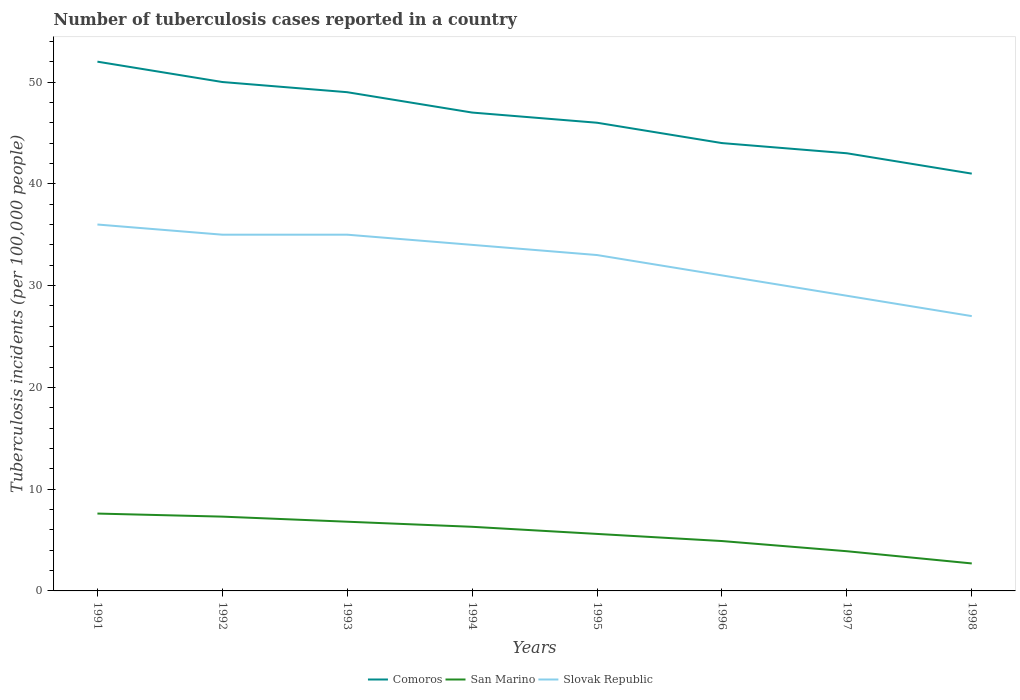Does the line corresponding to Slovak Republic intersect with the line corresponding to San Marino?
Your response must be concise. No. Across all years, what is the maximum number of tuberculosis cases reported in in Slovak Republic?
Offer a terse response. 27. In which year was the number of tuberculosis cases reported in in San Marino maximum?
Your answer should be compact. 1998. What is the difference between the highest and the second highest number of tuberculosis cases reported in in Comoros?
Your response must be concise. 11. Is the number of tuberculosis cases reported in in Slovak Republic strictly greater than the number of tuberculosis cases reported in in Comoros over the years?
Provide a succinct answer. Yes. What is the difference between two consecutive major ticks on the Y-axis?
Ensure brevity in your answer.  10. Are the values on the major ticks of Y-axis written in scientific E-notation?
Offer a terse response. No. Does the graph contain any zero values?
Offer a very short reply. No. Does the graph contain grids?
Provide a succinct answer. No. How are the legend labels stacked?
Provide a succinct answer. Horizontal. What is the title of the graph?
Give a very brief answer. Number of tuberculosis cases reported in a country. Does "Peru" appear as one of the legend labels in the graph?
Your answer should be compact. No. What is the label or title of the X-axis?
Offer a terse response. Years. What is the label or title of the Y-axis?
Your response must be concise. Tuberculosis incidents (per 100,0 people). What is the Tuberculosis incidents (per 100,000 people) in San Marino in 1991?
Your answer should be very brief. 7.6. What is the Tuberculosis incidents (per 100,000 people) of Slovak Republic in 1992?
Your answer should be compact. 35. What is the Tuberculosis incidents (per 100,000 people) in San Marino in 1994?
Your answer should be compact. 6.3. What is the Tuberculosis incidents (per 100,000 people) of Slovak Republic in 1994?
Give a very brief answer. 34. What is the Tuberculosis incidents (per 100,000 people) of Comoros in 1995?
Keep it short and to the point. 46. What is the Tuberculosis incidents (per 100,000 people) of Slovak Republic in 1995?
Ensure brevity in your answer.  33. What is the Tuberculosis incidents (per 100,000 people) of San Marino in 1996?
Give a very brief answer. 4.9. What is the Tuberculosis incidents (per 100,000 people) of San Marino in 1997?
Offer a very short reply. 3.9. What is the Tuberculosis incidents (per 100,000 people) in Comoros in 1998?
Keep it short and to the point. 41. What is the Tuberculosis incidents (per 100,000 people) in Slovak Republic in 1998?
Provide a short and direct response. 27. Across all years, what is the maximum Tuberculosis incidents (per 100,000 people) in Comoros?
Make the answer very short. 52. Across all years, what is the maximum Tuberculosis incidents (per 100,000 people) in Slovak Republic?
Give a very brief answer. 36. Across all years, what is the minimum Tuberculosis incidents (per 100,000 people) in San Marino?
Make the answer very short. 2.7. Across all years, what is the minimum Tuberculosis incidents (per 100,000 people) in Slovak Republic?
Offer a terse response. 27. What is the total Tuberculosis incidents (per 100,000 people) in Comoros in the graph?
Your answer should be compact. 372. What is the total Tuberculosis incidents (per 100,000 people) of San Marino in the graph?
Make the answer very short. 45.1. What is the total Tuberculosis incidents (per 100,000 people) in Slovak Republic in the graph?
Provide a short and direct response. 260. What is the difference between the Tuberculosis incidents (per 100,000 people) in Comoros in 1991 and that in 1992?
Offer a very short reply. 2. What is the difference between the Tuberculosis incidents (per 100,000 people) of San Marino in 1991 and that in 1993?
Ensure brevity in your answer.  0.8. What is the difference between the Tuberculosis incidents (per 100,000 people) in Slovak Republic in 1991 and that in 1993?
Your answer should be very brief. 1. What is the difference between the Tuberculosis incidents (per 100,000 people) of Comoros in 1991 and that in 1994?
Give a very brief answer. 5. What is the difference between the Tuberculosis incidents (per 100,000 people) in San Marino in 1991 and that in 1994?
Give a very brief answer. 1.3. What is the difference between the Tuberculosis incidents (per 100,000 people) of Comoros in 1991 and that in 1995?
Ensure brevity in your answer.  6. What is the difference between the Tuberculosis incidents (per 100,000 people) in Slovak Republic in 1991 and that in 1995?
Give a very brief answer. 3. What is the difference between the Tuberculosis incidents (per 100,000 people) of Comoros in 1991 and that in 1996?
Provide a succinct answer. 8. What is the difference between the Tuberculosis incidents (per 100,000 people) in San Marino in 1991 and that in 1998?
Keep it short and to the point. 4.9. What is the difference between the Tuberculosis incidents (per 100,000 people) in Comoros in 1992 and that in 1993?
Make the answer very short. 1. What is the difference between the Tuberculosis incidents (per 100,000 people) in San Marino in 1992 and that in 1993?
Offer a very short reply. 0.5. What is the difference between the Tuberculosis incidents (per 100,000 people) in San Marino in 1992 and that in 1994?
Ensure brevity in your answer.  1. What is the difference between the Tuberculosis incidents (per 100,000 people) of Slovak Republic in 1992 and that in 1995?
Offer a terse response. 2. What is the difference between the Tuberculosis incidents (per 100,000 people) of San Marino in 1992 and that in 1996?
Your response must be concise. 2.4. What is the difference between the Tuberculosis incidents (per 100,000 people) in Slovak Republic in 1992 and that in 1996?
Your response must be concise. 4. What is the difference between the Tuberculosis incidents (per 100,000 people) in Comoros in 1992 and that in 1997?
Keep it short and to the point. 7. What is the difference between the Tuberculosis incidents (per 100,000 people) in San Marino in 1992 and that in 1997?
Give a very brief answer. 3.4. What is the difference between the Tuberculosis incidents (per 100,000 people) of Slovak Republic in 1992 and that in 1997?
Keep it short and to the point. 6. What is the difference between the Tuberculosis incidents (per 100,000 people) in Slovak Republic in 1992 and that in 1998?
Provide a short and direct response. 8. What is the difference between the Tuberculosis incidents (per 100,000 people) of San Marino in 1993 and that in 1994?
Make the answer very short. 0.5. What is the difference between the Tuberculosis incidents (per 100,000 people) in Slovak Republic in 1993 and that in 1994?
Provide a succinct answer. 1. What is the difference between the Tuberculosis incidents (per 100,000 people) in Comoros in 1993 and that in 1995?
Ensure brevity in your answer.  3. What is the difference between the Tuberculosis incidents (per 100,000 people) of Slovak Republic in 1993 and that in 1995?
Make the answer very short. 2. What is the difference between the Tuberculosis incidents (per 100,000 people) of San Marino in 1993 and that in 1996?
Make the answer very short. 1.9. What is the difference between the Tuberculosis incidents (per 100,000 people) in Slovak Republic in 1993 and that in 1996?
Keep it short and to the point. 4. What is the difference between the Tuberculosis incidents (per 100,000 people) of Slovak Republic in 1993 and that in 1997?
Provide a short and direct response. 6. What is the difference between the Tuberculosis incidents (per 100,000 people) of Comoros in 1993 and that in 1998?
Provide a succinct answer. 8. What is the difference between the Tuberculosis incidents (per 100,000 people) of San Marino in 1994 and that in 1995?
Offer a very short reply. 0.7. What is the difference between the Tuberculosis incidents (per 100,000 people) of Comoros in 1994 and that in 1996?
Offer a terse response. 3. What is the difference between the Tuberculosis incidents (per 100,000 people) in Slovak Republic in 1994 and that in 1996?
Offer a very short reply. 3. What is the difference between the Tuberculosis incidents (per 100,000 people) in Comoros in 1994 and that in 1997?
Provide a succinct answer. 4. What is the difference between the Tuberculosis incidents (per 100,000 people) in Slovak Republic in 1994 and that in 1997?
Provide a short and direct response. 5. What is the difference between the Tuberculosis incidents (per 100,000 people) of Comoros in 1994 and that in 1998?
Keep it short and to the point. 6. What is the difference between the Tuberculosis incidents (per 100,000 people) in San Marino in 1994 and that in 1998?
Offer a terse response. 3.6. What is the difference between the Tuberculosis incidents (per 100,000 people) of Slovak Republic in 1994 and that in 1998?
Your response must be concise. 7. What is the difference between the Tuberculosis incidents (per 100,000 people) of Slovak Republic in 1995 and that in 1996?
Keep it short and to the point. 2. What is the difference between the Tuberculosis incidents (per 100,000 people) in Comoros in 1995 and that in 1998?
Give a very brief answer. 5. What is the difference between the Tuberculosis incidents (per 100,000 people) of Comoros in 1996 and that in 1997?
Your answer should be compact. 1. What is the difference between the Tuberculosis incidents (per 100,000 people) of San Marino in 1996 and that in 1997?
Provide a succinct answer. 1. What is the difference between the Tuberculosis incidents (per 100,000 people) in Slovak Republic in 1996 and that in 1997?
Make the answer very short. 2. What is the difference between the Tuberculosis incidents (per 100,000 people) in Comoros in 1997 and that in 1998?
Your answer should be compact. 2. What is the difference between the Tuberculosis incidents (per 100,000 people) of Slovak Republic in 1997 and that in 1998?
Offer a very short reply. 2. What is the difference between the Tuberculosis incidents (per 100,000 people) in Comoros in 1991 and the Tuberculosis incidents (per 100,000 people) in San Marino in 1992?
Offer a terse response. 44.7. What is the difference between the Tuberculosis incidents (per 100,000 people) in Comoros in 1991 and the Tuberculosis incidents (per 100,000 people) in Slovak Republic in 1992?
Offer a terse response. 17. What is the difference between the Tuberculosis incidents (per 100,000 people) in San Marino in 1991 and the Tuberculosis incidents (per 100,000 people) in Slovak Republic in 1992?
Your response must be concise. -27.4. What is the difference between the Tuberculosis incidents (per 100,000 people) in Comoros in 1991 and the Tuberculosis incidents (per 100,000 people) in San Marino in 1993?
Your answer should be very brief. 45.2. What is the difference between the Tuberculosis incidents (per 100,000 people) in Comoros in 1991 and the Tuberculosis incidents (per 100,000 people) in Slovak Republic in 1993?
Provide a short and direct response. 17. What is the difference between the Tuberculosis incidents (per 100,000 people) of San Marino in 1991 and the Tuberculosis incidents (per 100,000 people) of Slovak Republic in 1993?
Offer a very short reply. -27.4. What is the difference between the Tuberculosis incidents (per 100,000 people) in Comoros in 1991 and the Tuberculosis incidents (per 100,000 people) in San Marino in 1994?
Offer a very short reply. 45.7. What is the difference between the Tuberculosis incidents (per 100,000 people) in Comoros in 1991 and the Tuberculosis incidents (per 100,000 people) in Slovak Republic in 1994?
Ensure brevity in your answer.  18. What is the difference between the Tuberculosis incidents (per 100,000 people) of San Marino in 1991 and the Tuberculosis incidents (per 100,000 people) of Slovak Republic in 1994?
Provide a short and direct response. -26.4. What is the difference between the Tuberculosis incidents (per 100,000 people) of Comoros in 1991 and the Tuberculosis incidents (per 100,000 people) of San Marino in 1995?
Offer a terse response. 46.4. What is the difference between the Tuberculosis incidents (per 100,000 people) in Comoros in 1991 and the Tuberculosis incidents (per 100,000 people) in Slovak Republic in 1995?
Your answer should be compact. 19. What is the difference between the Tuberculosis incidents (per 100,000 people) of San Marino in 1991 and the Tuberculosis incidents (per 100,000 people) of Slovak Republic in 1995?
Your answer should be very brief. -25.4. What is the difference between the Tuberculosis incidents (per 100,000 people) in Comoros in 1991 and the Tuberculosis incidents (per 100,000 people) in San Marino in 1996?
Give a very brief answer. 47.1. What is the difference between the Tuberculosis incidents (per 100,000 people) in Comoros in 1991 and the Tuberculosis incidents (per 100,000 people) in Slovak Republic in 1996?
Give a very brief answer. 21. What is the difference between the Tuberculosis incidents (per 100,000 people) in San Marino in 1991 and the Tuberculosis incidents (per 100,000 people) in Slovak Republic in 1996?
Make the answer very short. -23.4. What is the difference between the Tuberculosis incidents (per 100,000 people) in Comoros in 1991 and the Tuberculosis incidents (per 100,000 people) in San Marino in 1997?
Your answer should be compact. 48.1. What is the difference between the Tuberculosis incidents (per 100,000 people) in Comoros in 1991 and the Tuberculosis incidents (per 100,000 people) in Slovak Republic in 1997?
Your answer should be very brief. 23. What is the difference between the Tuberculosis incidents (per 100,000 people) of San Marino in 1991 and the Tuberculosis incidents (per 100,000 people) of Slovak Republic in 1997?
Your response must be concise. -21.4. What is the difference between the Tuberculosis incidents (per 100,000 people) in Comoros in 1991 and the Tuberculosis incidents (per 100,000 people) in San Marino in 1998?
Provide a short and direct response. 49.3. What is the difference between the Tuberculosis incidents (per 100,000 people) in Comoros in 1991 and the Tuberculosis incidents (per 100,000 people) in Slovak Republic in 1998?
Keep it short and to the point. 25. What is the difference between the Tuberculosis incidents (per 100,000 people) in San Marino in 1991 and the Tuberculosis incidents (per 100,000 people) in Slovak Republic in 1998?
Your answer should be very brief. -19.4. What is the difference between the Tuberculosis incidents (per 100,000 people) of Comoros in 1992 and the Tuberculosis incidents (per 100,000 people) of San Marino in 1993?
Your answer should be very brief. 43.2. What is the difference between the Tuberculosis incidents (per 100,000 people) of Comoros in 1992 and the Tuberculosis incidents (per 100,000 people) of Slovak Republic in 1993?
Offer a terse response. 15. What is the difference between the Tuberculosis incidents (per 100,000 people) in San Marino in 1992 and the Tuberculosis incidents (per 100,000 people) in Slovak Republic in 1993?
Give a very brief answer. -27.7. What is the difference between the Tuberculosis incidents (per 100,000 people) of Comoros in 1992 and the Tuberculosis incidents (per 100,000 people) of San Marino in 1994?
Give a very brief answer. 43.7. What is the difference between the Tuberculosis incidents (per 100,000 people) of Comoros in 1992 and the Tuberculosis incidents (per 100,000 people) of Slovak Republic in 1994?
Provide a succinct answer. 16. What is the difference between the Tuberculosis incidents (per 100,000 people) in San Marino in 1992 and the Tuberculosis incidents (per 100,000 people) in Slovak Republic in 1994?
Give a very brief answer. -26.7. What is the difference between the Tuberculosis incidents (per 100,000 people) in Comoros in 1992 and the Tuberculosis incidents (per 100,000 people) in San Marino in 1995?
Offer a terse response. 44.4. What is the difference between the Tuberculosis incidents (per 100,000 people) of San Marino in 1992 and the Tuberculosis incidents (per 100,000 people) of Slovak Republic in 1995?
Provide a succinct answer. -25.7. What is the difference between the Tuberculosis incidents (per 100,000 people) in Comoros in 1992 and the Tuberculosis incidents (per 100,000 people) in San Marino in 1996?
Keep it short and to the point. 45.1. What is the difference between the Tuberculosis incidents (per 100,000 people) in San Marino in 1992 and the Tuberculosis incidents (per 100,000 people) in Slovak Republic in 1996?
Provide a succinct answer. -23.7. What is the difference between the Tuberculosis incidents (per 100,000 people) of Comoros in 1992 and the Tuberculosis incidents (per 100,000 people) of San Marino in 1997?
Offer a terse response. 46.1. What is the difference between the Tuberculosis incidents (per 100,000 people) in Comoros in 1992 and the Tuberculosis incidents (per 100,000 people) in Slovak Republic in 1997?
Make the answer very short. 21. What is the difference between the Tuberculosis incidents (per 100,000 people) in San Marino in 1992 and the Tuberculosis incidents (per 100,000 people) in Slovak Republic in 1997?
Offer a very short reply. -21.7. What is the difference between the Tuberculosis incidents (per 100,000 people) of Comoros in 1992 and the Tuberculosis incidents (per 100,000 people) of San Marino in 1998?
Ensure brevity in your answer.  47.3. What is the difference between the Tuberculosis incidents (per 100,000 people) in Comoros in 1992 and the Tuberculosis incidents (per 100,000 people) in Slovak Republic in 1998?
Your answer should be very brief. 23. What is the difference between the Tuberculosis incidents (per 100,000 people) of San Marino in 1992 and the Tuberculosis incidents (per 100,000 people) of Slovak Republic in 1998?
Your answer should be very brief. -19.7. What is the difference between the Tuberculosis incidents (per 100,000 people) of Comoros in 1993 and the Tuberculosis incidents (per 100,000 people) of San Marino in 1994?
Give a very brief answer. 42.7. What is the difference between the Tuberculosis incidents (per 100,000 people) of San Marino in 1993 and the Tuberculosis incidents (per 100,000 people) of Slovak Republic in 1994?
Ensure brevity in your answer.  -27.2. What is the difference between the Tuberculosis incidents (per 100,000 people) in Comoros in 1993 and the Tuberculosis incidents (per 100,000 people) in San Marino in 1995?
Make the answer very short. 43.4. What is the difference between the Tuberculosis incidents (per 100,000 people) in San Marino in 1993 and the Tuberculosis incidents (per 100,000 people) in Slovak Republic in 1995?
Your answer should be compact. -26.2. What is the difference between the Tuberculosis incidents (per 100,000 people) of Comoros in 1993 and the Tuberculosis incidents (per 100,000 people) of San Marino in 1996?
Offer a terse response. 44.1. What is the difference between the Tuberculosis incidents (per 100,000 people) of San Marino in 1993 and the Tuberculosis incidents (per 100,000 people) of Slovak Republic in 1996?
Ensure brevity in your answer.  -24.2. What is the difference between the Tuberculosis incidents (per 100,000 people) in Comoros in 1993 and the Tuberculosis incidents (per 100,000 people) in San Marino in 1997?
Your answer should be very brief. 45.1. What is the difference between the Tuberculosis incidents (per 100,000 people) of Comoros in 1993 and the Tuberculosis incidents (per 100,000 people) of Slovak Republic in 1997?
Your answer should be compact. 20. What is the difference between the Tuberculosis incidents (per 100,000 people) in San Marino in 1993 and the Tuberculosis incidents (per 100,000 people) in Slovak Republic in 1997?
Your response must be concise. -22.2. What is the difference between the Tuberculosis incidents (per 100,000 people) in Comoros in 1993 and the Tuberculosis incidents (per 100,000 people) in San Marino in 1998?
Your answer should be compact. 46.3. What is the difference between the Tuberculosis incidents (per 100,000 people) of San Marino in 1993 and the Tuberculosis incidents (per 100,000 people) of Slovak Republic in 1998?
Keep it short and to the point. -20.2. What is the difference between the Tuberculosis incidents (per 100,000 people) in Comoros in 1994 and the Tuberculosis incidents (per 100,000 people) in San Marino in 1995?
Give a very brief answer. 41.4. What is the difference between the Tuberculosis incidents (per 100,000 people) in San Marino in 1994 and the Tuberculosis incidents (per 100,000 people) in Slovak Republic in 1995?
Offer a very short reply. -26.7. What is the difference between the Tuberculosis incidents (per 100,000 people) of Comoros in 1994 and the Tuberculosis incidents (per 100,000 people) of San Marino in 1996?
Offer a terse response. 42.1. What is the difference between the Tuberculosis incidents (per 100,000 people) of San Marino in 1994 and the Tuberculosis incidents (per 100,000 people) of Slovak Republic in 1996?
Your answer should be very brief. -24.7. What is the difference between the Tuberculosis incidents (per 100,000 people) of Comoros in 1994 and the Tuberculosis incidents (per 100,000 people) of San Marino in 1997?
Offer a terse response. 43.1. What is the difference between the Tuberculosis incidents (per 100,000 people) in San Marino in 1994 and the Tuberculosis incidents (per 100,000 people) in Slovak Republic in 1997?
Keep it short and to the point. -22.7. What is the difference between the Tuberculosis incidents (per 100,000 people) in Comoros in 1994 and the Tuberculosis incidents (per 100,000 people) in San Marino in 1998?
Your answer should be very brief. 44.3. What is the difference between the Tuberculosis incidents (per 100,000 people) of Comoros in 1994 and the Tuberculosis incidents (per 100,000 people) of Slovak Republic in 1998?
Keep it short and to the point. 20. What is the difference between the Tuberculosis incidents (per 100,000 people) in San Marino in 1994 and the Tuberculosis incidents (per 100,000 people) in Slovak Republic in 1998?
Your answer should be very brief. -20.7. What is the difference between the Tuberculosis incidents (per 100,000 people) in Comoros in 1995 and the Tuberculosis incidents (per 100,000 people) in San Marino in 1996?
Your answer should be compact. 41.1. What is the difference between the Tuberculosis incidents (per 100,000 people) of San Marino in 1995 and the Tuberculosis incidents (per 100,000 people) of Slovak Republic in 1996?
Give a very brief answer. -25.4. What is the difference between the Tuberculosis incidents (per 100,000 people) of Comoros in 1995 and the Tuberculosis incidents (per 100,000 people) of San Marino in 1997?
Offer a terse response. 42.1. What is the difference between the Tuberculosis incidents (per 100,000 people) of San Marino in 1995 and the Tuberculosis incidents (per 100,000 people) of Slovak Republic in 1997?
Your answer should be very brief. -23.4. What is the difference between the Tuberculosis incidents (per 100,000 people) of Comoros in 1995 and the Tuberculosis incidents (per 100,000 people) of San Marino in 1998?
Offer a terse response. 43.3. What is the difference between the Tuberculosis incidents (per 100,000 people) in San Marino in 1995 and the Tuberculosis incidents (per 100,000 people) in Slovak Republic in 1998?
Provide a succinct answer. -21.4. What is the difference between the Tuberculosis incidents (per 100,000 people) in Comoros in 1996 and the Tuberculosis incidents (per 100,000 people) in San Marino in 1997?
Offer a terse response. 40.1. What is the difference between the Tuberculosis incidents (per 100,000 people) of San Marino in 1996 and the Tuberculosis incidents (per 100,000 people) of Slovak Republic in 1997?
Ensure brevity in your answer.  -24.1. What is the difference between the Tuberculosis incidents (per 100,000 people) in Comoros in 1996 and the Tuberculosis incidents (per 100,000 people) in San Marino in 1998?
Keep it short and to the point. 41.3. What is the difference between the Tuberculosis incidents (per 100,000 people) in Comoros in 1996 and the Tuberculosis incidents (per 100,000 people) in Slovak Republic in 1998?
Keep it short and to the point. 17. What is the difference between the Tuberculosis incidents (per 100,000 people) of San Marino in 1996 and the Tuberculosis incidents (per 100,000 people) of Slovak Republic in 1998?
Provide a succinct answer. -22.1. What is the difference between the Tuberculosis incidents (per 100,000 people) in Comoros in 1997 and the Tuberculosis incidents (per 100,000 people) in San Marino in 1998?
Provide a succinct answer. 40.3. What is the difference between the Tuberculosis incidents (per 100,000 people) of Comoros in 1997 and the Tuberculosis incidents (per 100,000 people) of Slovak Republic in 1998?
Provide a short and direct response. 16. What is the difference between the Tuberculosis incidents (per 100,000 people) of San Marino in 1997 and the Tuberculosis incidents (per 100,000 people) of Slovak Republic in 1998?
Give a very brief answer. -23.1. What is the average Tuberculosis incidents (per 100,000 people) in Comoros per year?
Ensure brevity in your answer.  46.5. What is the average Tuberculosis incidents (per 100,000 people) of San Marino per year?
Make the answer very short. 5.64. What is the average Tuberculosis incidents (per 100,000 people) in Slovak Republic per year?
Offer a very short reply. 32.5. In the year 1991, what is the difference between the Tuberculosis incidents (per 100,000 people) of Comoros and Tuberculosis incidents (per 100,000 people) of San Marino?
Offer a terse response. 44.4. In the year 1991, what is the difference between the Tuberculosis incidents (per 100,000 people) of San Marino and Tuberculosis incidents (per 100,000 people) of Slovak Republic?
Keep it short and to the point. -28.4. In the year 1992, what is the difference between the Tuberculosis incidents (per 100,000 people) in Comoros and Tuberculosis incidents (per 100,000 people) in San Marino?
Your answer should be compact. 42.7. In the year 1992, what is the difference between the Tuberculosis incidents (per 100,000 people) in Comoros and Tuberculosis incidents (per 100,000 people) in Slovak Republic?
Your response must be concise. 15. In the year 1992, what is the difference between the Tuberculosis incidents (per 100,000 people) in San Marino and Tuberculosis incidents (per 100,000 people) in Slovak Republic?
Offer a terse response. -27.7. In the year 1993, what is the difference between the Tuberculosis incidents (per 100,000 people) of Comoros and Tuberculosis incidents (per 100,000 people) of San Marino?
Your response must be concise. 42.2. In the year 1993, what is the difference between the Tuberculosis incidents (per 100,000 people) in Comoros and Tuberculosis incidents (per 100,000 people) in Slovak Republic?
Provide a short and direct response. 14. In the year 1993, what is the difference between the Tuberculosis incidents (per 100,000 people) of San Marino and Tuberculosis incidents (per 100,000 people) of Slovak Republic?
Your response must be concise. -28.2. In the year 1994, what is the difference between the Tuberculosis incidents (per 100,000 people) in Comoros and Tuberculosis incidents (per 100,000 people) in San Marino?
Give a very brief answer. 40.7. In the year 1994, what is the difference between the Tuberculosis incidents (per 100,000 people) of Comoros and Tuberculosis incidents (per 100,000 people) of Slovak Republic?
Provide a succinct answer. 13. In the year 1994, what is the difference between the Tuberculosis incidents (per 100,000 people) in San Marino and Tuberculosis incidents (per 100,000 people) in Slovak Republic?
Ensure brevity in your answer.  -27.7. In the year 1995, what is the difference between the Tuberculosis incidents (per 100,000 people) in Comoros and Tuberculosis incidents (per 100,000 people) in San Marino?
Offer a very short reply. 40.4. In the year 1995, what is the difference between the Tuberculosis incidents (per 100,000 people) in San Marino and Tuberculosis incidents (per 100,000 people) in Slovak Republic?
Give a very brief answer. -27.4. In the year 1996, what is the difference between the Tuberculosis incidents (per 100,000 people) in Comoros and Tuberculosis incidents (per 100,000 people) in San Marino?
Give a very brief answer. 39.1. In the year 1996, what is the difference between the Tuberculosis incidents (per 100,000 people) in San Marino and Tuberculosis incidents (per 100,000 people) in Slovak Republic?
Ensure brevity in your answer.  -26.1. In the year 1997, what is the difference between the Tuberculosis incidents (per 100,000 people) of Comoros and Tuberculosis incidents (per 100,000 people) of San Marino?
Your answer should be very brief. 39.1. In the year 1997, what is the difference between the Tuberculosis incidents (per 100,000 people) of Comoros and Tuberculosis incidents (per 100,000 people) of Slovak Republic?
Give a very brief answer. 14. In the year 1997, what is the difference between the Tuberculosis incidents (per 100,000 people) of San Marino and Tuberculosis incidents (per 100,000 people) of Slovak Republic?
Keep it short and to the point. -25.1. In the year 1998, what is the difference between the Tuberculosis incidents (per 100,000 people) of Comoros and Tuberculosis incidents (per 100,000 people) of San Marino?
Make the answer very short. 38.3. In the year 1998, what is the difference between the Tuberculosis incidents (per 100,000 people) in Comoros and Tuberculosis incidents (per 100,000 people) in Slovak Republic?
Give a very brief answer. 14. In the year 1998, what is the difference between the Tuberculosis incidents (per 100,000 people) in San Marino and Tuberculosis incidents (per 100,000 people) in Slovak Republic?
Provide a succinct answer. -24.3. What is the ratio of the Tuberculosis incidents (per 100,000 people) of Comoros in 1991 to that in 1992?
Offer a very short reply. 1.04. What is the ratio of the Tuberculosis incidents (per 100,000 people) of San Marino in 1991 to that in 1992?
Your answer should be very brief. 1.04. What is the ratio of the Tuberculosis incidents (per 100,000 people) in Slovak Republic in 1991 to that in 1992?
Ensure brevity in your answer.  1.03. What is the ratio of the Tuberculosis incidents (per 100,000 people) of Comoros in 1991 to that in 1993?
Your answer should be compact. 1.06. What is the ratio of the Tuberculosis incidents (per 100,000 people) of San Marino in 1991 to that in 1993?
Ensure brevity in your answer.  1.12. What is the ratio of the Tuberculosis incidents (per 100,000 people) in Slovak Republic in 1991 to that in 1993?
Your answer should be very brief. 1.03. What is the ratio of the Tuberculosis incidents (per 100,000 people) in Comoros in 1991 to that in 1994?
Ensure brevity in your answer.  1.11. What is the ratio of the Tuberculosis incidents (per 100,000 people) in San Marino in 1991 to that in 1994?
Your answer should be very brief. 1.21. What is the ratio of the Tuberculosis incidents (per 100,000 people) in Slovak Republic in 1991 to that in 1994?
Your response must be concise. 1.06. What is the ratio of the Tuberculosis incidents (per 100,000 people) in Comoros in 1991 to that in 1995?
Make the answer very short. 1.13. What is the ratio of the Tuberculosis incidents (per 100,000 people) in San Marino in 1991 to that in 1995?
Your answer should be compact. 1.36. What is the ratio of the Tuberculosis incidents (per 100,000 people) in Comoros in 1991 to that in 1996?
Give a very brief answer. 1.18. What is the ratio of the Tuberculosis incidents (per 100,000 people) in San Marino in 1991 to that in 1996?
Keep it short and to the point. 1.55. What is the ratio of the Tuberculosis incidents (per 100,000 people) of Slovak Republic in 1991 to that in 1996?
Your answer should be compact. 1.16. What is the ratio of the Tuberculosis incidents (per 100,000 people) in Comoros in 1991 to that in 1997?
Make the answer very short. 1.21. What is the ratio of the Tuberculosis incidents (per 100,000 people) of San Marino in 1991 to that in 1997?
Give a very brief answer. 1.95. What is the ratio of the Tuberculosis incidents (per 100,000 people) in Slovak Republic in 1991 to that in 1997?
Ensure brevity in your answer.  1.24. What is the ratio of the Tuberculosis incidents (per 100,000 people) of Comoros in 1991 to that in 1998?
Provide a succinct answer. 1.27. What is the ratio of the Tuberculosis incidents (per 100,000 people) in San Marino in 1991 to that in 1998?
Your response must be concise. 2.81. What is the ratio of the Tuberculosis incidents (per 100,000 people) in Slovak Republic in 1991 to that in 1998?
Keep it short and to the point. 1.33. What is the ratio of the Tuberculosis incidents (per 100,000 people) of Comoros in 1992 to that in 1993?
Give a very brief answer. 1.02. What is the ratio of the Tuberculosis incidents (per 100,000 people) of San Marino in 1992 to that in 1993?
Make the answer very short. 1.07. What is the ratio of the Tuberculosis incidents (per 100,000 people) of Comoros in 1992 to that in 1994?
Your answer should be compact. 1.06. What is the ratio of the Tuberculosis incidents (per 100,000 people) in San Marino in 1992 to that in 1994?
Make the answer very short. 1.16. What is the ratio of the Tuberculosis incidents (per 100,000 people) in Slovak Republic in 1992 to that in 1994?
Keep it short and to the point. 1.03. What is the ratio of the Tuberculosis incidents (per 100,000 people) of Comoros in 1992 to that in 1995?
Your response must be concise. 1.09. What is the ratio of the Tuberculosis incidents (per 100,000 people) in San Marino in 1992 to that in 1995?
Make the answer very short. 1.3. What is the ratio of the Tuberculosis incidents (per 100,000 people) of Slovak Republic in 1992 to that in 1995?
Offer a terse response. 1.06. What is the ratio of the Tuberculosis incidents (per 100,000 people) of Comoros in 1992 to that in 1996?
Your response must be concise. 1.14. What is the ratio of the Tuberculosis incidents (per 100,000 people) of San Marino in 1992 to that in 1996?
Your response must be concise. 1.49. What is the ratio of the Tuberculosis incidents (per 100,000 people) of Slovak Republic in 1992 to that in 1996?
Your response must be concise. 1.13. What is the ratio of the Tuberculosis incidents (per 100,000 people) in Comoros in 1992 to that in 1997?
Give a very brief answer. 1.16. What is the ratio of the Tuberculosis incidents (per 100,000 people) of San Marino in 1992 to that in 1997?
Provide a succinct answer. 1.87. What is the ratio of the Tuberculosis incidents (per 100,000 people) in Slovak Republic in 1992 to that in 1997?
Ensure brevity in your answer.  1.21. What is the ratio of the Tuberculosis incidents (per 100,000 people) of Comoros in 1992 to that in 1998?
Your response must be concise. 1.22. What is the ratio of the Tuberculosis incidents (per 100,000 people) of San Marino in 1992 to that in 1998?
Keep it short and to the point. 2.7. What is the ratio of the Tuberculosis incidents (per 100,000 people) of Slovak Republic in 1992 to that in 1998?
Provide a short and direct response. 1.3. What is the ratio of the Tuberculosis incidents (per 100,000 people) in Comoros in 1993 to that in 1994?
Ensure brevity in your answer.  1.04. What is the ratio of the Tuberculosis incidents (per 100,000 people) in San Marino in 1993 to that in 1994?
Ensure brevity in your answer.  1.08. What is the ratio of the Tuberculosis incidents (per 100,000 people) in Slovak Republic in 1993 to that in 1994?
Your answer should be compact. 1.03. What is the ratio of the Tuberculosis incidents (per 100,000 people) in Comoros in 1993 to that in 1995?
Provide a succinct answer. 1.07. What is the ratio of the Tuberculosis incidents (per 100,000 people) in San Marino in 1993 to that in 1995?
Make the answer very short. 1.21. What is the ratio of the Tuberculosis incidents (per 100,000 people) in Slovak Republic in 1993 to that in 1995?
Offer a terse response. 1.06. What is the ratio of the Tuberculosis incidents (per 100,000 people) in Comoros in 1993 to that in 1996?
Your response must be concise. 1.11. What is the ratio of the Tuberculosis incidents (per 100,000 people) of San Marino in 1993 to that in 1996?
Offer a very short reply. 1.39. What is the ratio of the Tuberculosis incidents (per 100,000 people) in Slovak Republic in 1993 to that in 1996?
Provide a succinct answer. 1.13. What is the ratio of the Tuberculosis incidents (per 100,000 people) of Comoros in 1993 to that in 1997?
Your response must be concise. 1.14. What is the ratio of the Tuberculosis incidents (per 100,000 people) in San Marino in 1993 to that in 1997?
Offer a terse response. 1.74. What is the ratio of the Tuberculosis incidents (per 100,000 people) in Slovak Republic in 1993 to that in 1997?
Your response must be concise. 1.21. What is the ratio of the Tuberculosis incidents (per 100,000 people) in Comoros in 1993 to that in 1998?
Your response must be concise. 1.2. What is the ratio of the Tuberculosis incidents (per 100,000 people) in San Marino in 1993 to that in 1998?
Provide a succinct answer. 2.52. What is the ratio of the Tuberculosis incidents (per 100,000 people) of Slovak Republic in 1993 to that in 1998?
Offer a terse response. 1.3. What is the ratio of the Tuberculosis incidents (per 100,000 people) in Comoros in 1994 to that in 1995?
Keep it short and to the point. 1.02. What is the ratio of the Tuberculosis incidents (per 100,000 people) in San Marino in 1994 to that in 1995?
Provide a short and direct response. 1.12. What is the ratio of the Tuberculosis incidents (per 100,000 people) of Slovak Republic in 1994 to that in 1995?
Ensure brevity in your answer.  1.03. What is the ratio of the Tuberculosis incidents (per 100,000 people) of Comoros in 1994 to that in 1996?
Your answer should be compact. 1.07. What is the ratio of the Tuberculosis incidents (per 100,000 people) in San Marino in 1994 to that in 1996?
Provide a short and direct response. 1.29. What is the ratio of the Tuberculosis incidents (per 100,000 people) in Slovak Republic in 1994 to that in 1996?
Offer a very short reply. 1.1. What is the ratio of the Tuberculosis incidents (per 100,000 people) in Comoros in 1994 to that in 1997?
Offer a very short reply. 1.09. What is the ratio of the Tuberculosis incidents (per 100,000 people) of San Marino in 1994 to that in 1997?
Offer a very short reply. 1.62. What is the ratio of the Tuberculosis incidents (per 100,000 people) in Slovak Republic in 1994 to that in 1997?
Provide a succinct answer. 1.17. What is the ratio of the Tuberculosis incidents (per 100,000 people) of Comoros in 1994 to that in 1998?
Offer a very short reply. 1.15. What is the ratio of the Tuberculosis incidents (per 100,000 people) of San Marino in 1994 to that in 1998?
Give a very brief answer. 2.33. What is the ratio of the Tuberculosis incidents (per 100,000 people) in Slovak Republic in 1994 to that in 1998?
Your answer should be compact. 1.26. What is the ratio of the Tuberculosis incidents (per 100,000 people) of Comoros in 1995 to that in 1996?
Provide a succinct answer. 1.05. What is the ratio of the Tuberculosis incidents (per 100,000 people) of San Marino in 1995 to that in 1996?
Offer a terse response. 1.14. What is the ratio of the Tuberculosis incidents (per 100,000 people) in Slovak Republic in 1995 to that in 1996?
Offer a terse response. 1.06. What is the ratio of the Tuberculosis incidents (per 100,000 people) of Comoros in 1995 to that in 1997?
Keep it short and to the point. 1.07. What is the ratio of the Tuberculosis incidents (per 100,000 people) in San Marino in 1995 to that in 1997?
Your answer should be very brief. 1.44. What is the ratio of the Tuberculosis incidents (per 100,000 people) of Slovak Republic in 1995 to that in 1997?
Provide a succinct answer. 1.14. What is the ratio of the Tuberculosis incidents (per 100,000 people) in Comoros in 1995 to that in 1998?
Give a very brief answer. 1.12. What is the ratio of the Tuberculosis incidents (per 100,000 people) in San Marino in 1995 to that in 1998?
Your answer should be very brief. 2.07. What is the ratio of the Tuberculosis incidents (per 100,000 people) in Slovak Republic in 1995 to that in 1998?
Offer a terse response. 1.22. What is the ratio of the Tuberculosis incidents (per 100,000 people) of Comoros in 1996 to that in 1997?
Offer a terse response. 1.02. What is the ratio of the Tuberculosis incidents (per 100,000 people) of San Marino in 1996 to that in 1997?
Give a very brief answer. 1.26. What is the ratio of the Tuberculosis incidents (per 100,000 people) in Slovak Republic in 1996 to that in 1997?
Give a very brief answer. 1.07. What is the ratio of the Tuberculosis incidents (per 100,000 people) in Comoros in 1996 to that in 1998?
Ensure brevity in your answer.  1.07. What is the ratio of the Tuberculosis incidents (per 100,000 people) in San Marino in 1996 to that in 1998?
Provide a succinct answer. 1.81. What is the ratio of the Tuberculosis incidents (per 100,000 people) in Slovak Republic in 1996 to that in 1998?
Offer a terse response. 1.15. What is the ratio of the Tuberculosis incidents (per 100,000 people) of Comoros in 1997 to that in 1998?
Provide a short and direct response. 1.05. What is the ratio of the Tuberculosis incidents (per 100,000 people) of San Marino in 1997 to that in 1998?
Your answer should be compact. 1.44. What is the ratio of the Tuberculosis incidents (per 100,000 people) in Slovak Republic in 1997 to that in 1998?
Make the answer very short. 1.07. What is the difference between the highest and the second highest Tuberculosis incidents (per 100,000 people) of Slovak Republic?
Provide a short and direct response. 1. What is the difference between the highest and the lowest Tuberculosis incidents (per 100,000 people) in Comoros?
Offer a very short reply. 11. What is the difference between the highest and the lowest Tuberculosis incidents (per 100,000 people) in Slovak Republic?
Your answer should be very brief. 9. 